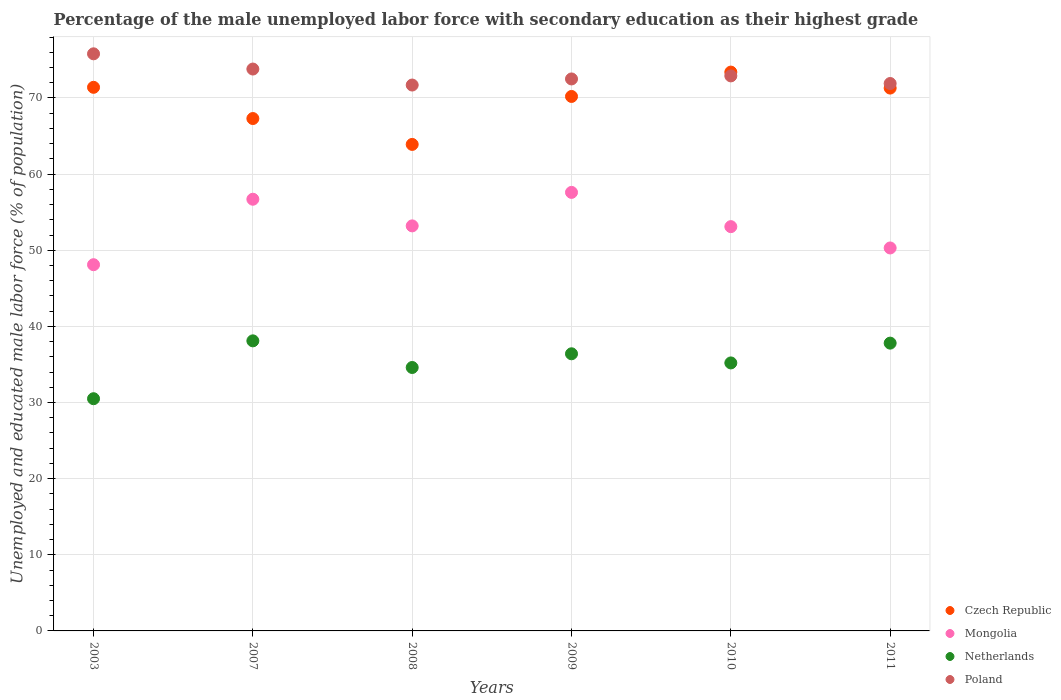Is the number of dotlines equal to the number of legend labels?
Make the answer very short. Yes. What is the percentage of the unemployed male labor force with secondary education in Poland in 2003?
Offer a very short reply. 75.8. Across all years, what is the maximum percentage of the unemployed male labor force with secondary education in Czech Republic?
Ensure brevity in your answer.  73.4. Across all years, what is the minimum percentage of the unemployed male labor force with secondary education in Czech Republic?
Your answer should be very brief. 63.9. In which year was the percentage of the unemployed male labor force with secondary education in Netherlands maximum?
Your answer should be compact. 2007. In which year was the percentage of the unemployed male labor force with secondary education in Czech Republic minimum?
Your answer should be very brief. 2008. What is the total percentage of the unemployed male labor force with secondary education in Mongolia in the graph?
Make the answer very short. 319. What is the difference between the percentage of the unemployed male labor force with secondary education in Poland in 2003 and the percentage of the unemployed male labor force with secondary education in Netherlands in 2010?
Offer a very short reply. 40.6. What is the average percentage of the unemployed male labor force with secondary education in Czech Republic per year?
Offer a terse response. 69.58. In the year 2008, what is the difference between the percentage of the unemployed male labor force with secondary education in Czech Republic and percentage of the unemployed male labor force with secondary education in Mongolia?
Make the answer very short. 10.7. What is the ratio of the percentage of the unemployed male labor force with secondary education in Mongolia in 2007 to that in 2010?
Provide a short and direct response. 1.07. Is the percentage of the unemployed male labor force with secondary education in Poland in 2010 less than that in 2011?
Ensure brevity in your answer.  No. What is the difference between the highest and the second highest percentage of the unemployed male labor force with secondary education in Czech Republic?
Your response must be concise. 2. What is the difference between the highest and the lowest percentage of the unemployed male labor force with secondary education in Czech Republic?
Provide a succinct answer. 9.5. Is it the case that in every year, the sum of the percentage of the unemployed male labor force with secondary education in Netherlands and percentage of the unemployed male labor force with secondary education in Mongolia  is greater than the sum of percentage of the unemployed male labor force with secondary education in Poland and percentage of the unemployed male labor force with secondary education in Czech Republic?
Keep it short and to the point. No. Is it the case that in every year, the sum of the percentage of the unemployed male labor force with secondary education in Mongolia and percentage of the unemployed male labor force with secondary education in Netherlands  is greater than the percentage of the unemployed male labor force with secondary education in Poland?
Provide a succinct answer. Yes. Does the percentage of the unemployed male labor force with secondary education in Czech Republic monotonically increase over the years?
Provide a succinct answer. No. How many years are there in the graph?
Your answer should be compact. 6. Does the graph contain any zero values?
Offer a terse response. No. Does the graph contain grids?
Offer a very short reply. Yes. Where does the legend appear in the graph?
Your response must be concise. Bottom right. How are the legend labels stacked?
Offer a terse response. Vertical. What is the title of the graph?
Ensure brevity in your answer.  Percentage of the male unemployed labor force with secondary education as their highest grade. Does "Brazil" appear as one of the legend labels in the graph?
Provide a short and direct response. No. What is the label or title of the Y-axis?
Your response must be concise. Unemployed and educated male labor force (% of population). What is the Unemployed and educated male labor force (% of population) of Czech Republic in 2003?
Ensure brevity in your answer.  71.4. What is the Unemployed and educated male labor force (% of population) of Mongolia in 2003?
Your answer should be very brief. 48.1. What is the Unemployed and educated male labor force (% of population) in Netherlands in 2003?
Provide a short and direct response. 30.5. What is the Unemployed and educated male labor force (% of population) in Poland in 2003?
Offer a very short reply. 75.8. What is the Unemployed and educated male labor force (% of population) of Czech Republic in 2007?
Make the answer very short. 67.3. What is the Unemployed and educated male labor force (% of population) of Mongolia in 2007?
Keep it short and to the point. 56.7. What is the Unemployed and educated male labor force (% of population) of Netherlands in 2007?
Provide a succinct answer. 38.1. What is the Unemployed and educated male labor force (% of population) in Poland in 2007?
Keep it short and to the point. 73.8. What is the Unemployed and educated male labor force (% of population) in Czech Republic in 2008?
Offer a terse response. 63.9. What is the Unemployed and educated male labor force (% of population) in Mongolia in 2008?
Your answer should be compact. 53.2. What is the Unemployed and educated male labor force (% of population) in Netherlands in 2008?
Offer a very short reply. 34.6. What is the Unemployed and educated male labor force (% of population) of Poland in 2008?
Provide a succinct answer. 71.7. What is the Unemployed and educated male labor force (% of population) of Czech Republic in 2009?
Your answer should be very brief. 70.2. What is the Unemployed and educated male labor force (% of population) of Mongolia in 2009?
Make the answer very short. 57.6. What is the Unemployed and educated male labor force (% of population) in Netherlands in 2009?
Your response must be concise. 36.4. What is the Unemployed and educated male labor force (% of population) in Poland in 2009?
Make the answer very short. 72.5. What is the Unemployed and educated male labor force (% of population) of Czech Republic in 2010?
Keep it short and to the point. 73.4. What is the Unemployed and educated male labor force (% of population) of Mongolia in 2010?
Your answer should be compact. 53.1. What is the Unemployed and educated male labor force (% of population) in Netherlands in 2010?
Your answer should be very brief. 35.2. What is the Unemployed and educated male labor force (% of population) of Poland in 2010?
Your response must be concise. 72.9. What is the Unemployed and educated male labor force (% of population) of Czech Republic in 2011?
Offer a very short reply. 71.3. What is the Unemployed and educated male labor force (% of population) in Mongolia in 2011?
Give a very brief answer. 50.3. What is the Unemployed and educated male labor force (% of population) of Netherlands in 2011?
Give a very brief answer. 37.8. What is the Unemployed and educated male labor force (% of population) of Poland in 2011?
Keep it short and to the point. 71.9. Across all years, what is the maximum Unemployed and educated male labor force (% of population) of Czech Republic?
Offer a very short reply. 73.4. Across all years, what is the maximum Unemployed and educated male labor force (% of population) in Mongolia?
Give a very brief answer. 57.6. Across all years, what is the maximum Unemployed and educated male labor force (% of population) in Netherlands?
Offer a very short reply. 38.1. Across all years, what is the maximum Unemployed and educated male labor force (% of population) of Poland?
Offer a very short reply. 75.8. Across all years, what is the minimum Unemployed and educated male labor force (% of population) of Czech Republic?
Your answer should be very brief. 63.9. Across all years, what is the minimum Unemployed and educated male labor force (% of population) of Mongolia?
Your answer should be compact. 48.1. Across all years, what is the minimum Unemployed and educated male labor force (% of population) of Netherlands?
Your response must be concise. 30.5. Across all years, what is the minimum Unemployed and educated male labor force (% of population) of Poland?
Provide a short and direct response. 71.7. What is the total Unemployed and educated male labor force (% of population) in Czech Republic in the graph?
Your answer should be compact. 417.5. What is the total Unemployed and educated male labor force (% of population) of Mongolia in the graph?
Offer a terse response. 319. What is the total Unemployed and educated male labor force (% of population) of Netherlands in the graph?
Offer a very short reply. 212.6. What is the total Unemployed and educated male labor force (% of population) of Poland in the graph?
Give a very brief answer. 438.6. What is the difference between the Unemployed and educated male labor force (% of population) in Czech Republic in 2003 and that in 2007?
Make the answer very short. 4.1. What is the difference between the Unemployed and educated male labor force (% of population) in Netherlands in 2003 and that in 2007?
Your response must be concise. -7.6. What is the difference between the Unemployed and educated male labor force (% of population) of Poland in 2003 and that in 2007?
Provide a short and direct response. 2. What is the difference between the Unemployed and educated male labor force (% of population) in Poland in 2003 and that in 2008?
Your answer should be very brief. 4.1. What is the difference between the Unemployed and educated male labor force (% of population) of Czech Republic in 2003 and that in 2009?
Your answer should be very brief. 1.2. What is the difference between the Unemployed and educated male labor force (% of population) in Netherlands in 2003 and that in 2009?
Your answer should be very brief. -5.9. What is the difference between the Unemployed and educated male labor force (% of population) in Poland in 2003 and that in 2009?
Provide a succinct answer. 3.3. What is the difference between the Unemployed and educated male labor force (% of population) in Mongolia in 2003 and that in 2010?
Give a very brief answer. -5. What is the difference between the Unemployed and educated male labor force (% of population) of Netherlands in 2003 and that in 2010?
Your answer should be compact. -4.7. What is the difference between the Unemployed and educated male labor force (% of population) in Poland in 2003 and that in 2010?
Give a very brief answer. 2.9. What is the difference between the Unemployed and educated male labor force (% of population) in Czech Republic in 2003 and that in 2011?
Give a very brief answer. 0.1. What is the difference between the Unemployed and educated male labor force (% of population) in Mongolia in 2003 and that in 2011?
Provide a short and direct response. -2.2. What is the difference between the Unemployed and educated male labor force (% of population) of Netherlands in 2003 and that in 2011?
Ensure brevity in your answer.  -7.3. What is the difference between the Unemployed and educated male labor force (% of population) in Poland in 2003 and that in 2011?
Make the answer very short. 3.9. What is the difference between the Unemployed and educated male labor force (% of population) in Czech Republic in 2007 and that in 2008?
Offer a very short reply. 3.4. What is the difference between the Unemployed and educated male labor force (% of population) in Mongolia in 2007 and that in 2008?
Provide a succinct answer. 3.5. What is the difference between the Unemployed and educated male labor force (% of population) in Netherlands in 2007 and that in 2008?
Provide a short and direct response. 3.5. What is the difference between the Unemployed and educated male labor force (% of population) of Poland in 2007 and that in 2008?
Offer a terse response. 2.1. What is the difference between the Unemployed and educated male labor force (% of population) in Mongolia in 2007 and that in 2009?
Make the answer very short. -0.9. What is the difference between the Unemployed and educated male labor force (% of population) in Poland in 2007 and that in 2009?
Your answer should be very brief. 1.3. What is the difference between the Unemployed and educated male labor force (% of population) of Mongolia in 2007 and that in 2010?
Provide a succinct answer. 3.6. What is the difference between the Unemployed and educated male labor force (% of population) of Poland in 2007 and that in 2010?
Provide a short and direct response. 0.9. What is the difference between the Unemployed and educated male labor force (% of population) in Mongolia in 2007 and that in 2011?
Offer a terse response. 6.4. What is the difference between the Unemployed and educated male labor force (% of population) of Netherlands in 2007 and that in 2011?
Make the answer very short. 0.3. What is the difference between the Unemployed and educated male labor force (% of population) of Poland in 2007 and that in 2011?
Your response must be concise. 1.9. What is the difference between the Unemployed and educated male labor force (% of population) in Mongolia in 2008 and that in 2010?
Keep it short and to the point. 0.1. What is the difference between the Unemployed and educated male labor force (% of population) of Mongolia in 2008 and that in 2011?
Keep it short and to the point. 2.9. What is the difference between the Unemployed and educated male labor force (% of population) in Poland in 2008 and that in 2011?
Provide a succinct answer. -0.2. What is the difference between the Unemployed and educated male labor force (% of population) of Mongolia in 2009 and that in 2010?
Provide a short and direct response. 4.5. What is the difference between the Unemployed and educated male labor force (% of population) in Netherlands in 2009 and that in 2010?
Ensure brevity in your answer.  1.2. What is the difference between the Unemployed and educated male labor force (% of population) of Poland in 2009 and that in 2010?
Offer a terse response. -0.4. What is the difference between the Unemployed and educated male labor force (% of population) in Poland in 2009 and that in 2011?
Give a very brief answer. 0.6. What is the difference between the Unemployed and educated male labor force (% of population) in Czech Republic in 2010 and that in 2011?
Your answer should be very brief. 2.1. What is the difference between the Unemployed and educated male labor force (% of population) of Mongolia in 2010 and that in 2011?
Offer a terse response. 2.8. What is the difference between the Unemployed and educated male labor force (% of population) in Netherlands in 2010 and that in 2011?
Provide a short and direct response. -2.6. What is the difference between the Unemployed and educated male labor force (% of population) of Czech Republic in 2003 and the Unemployed and educated male labor force (% of population) of Mongolia in 2007?
Ensure brevity in your answer.  14.7. What is the difference between the Unemployed and educated male labor force (% of population) in Czech Republic in 2003 and the Unemployed and educated male labor force (% of population) in Netherlands in 2007?
Provide a succinct answer. 33.3. What is the difference between the Unemployed and educated male labor force (% of population) of Mongolia in 2003 and the Unemployed and educated male labor force (% of population) of Poland in 2007?
Make the answer very short. -25.7. What is the difference between the Unemployed and educated male labor force (% of population) in Netherlands in 2003 and the Unemployed and educated male labor force (% of population) in Poland in 2007?
Provide a short and direct response. -43.3. What is the difference between the Unemployed and educated male labor force (% of population) in Czech Republic in 2003 and the Unemployed and educated male labor force (% of population) in Netherlands in 2008?
Make the answer very short. 36.8. What is the difference between the Unemployed and educated male labor force (% of population) in Mongolia in 2003 and the Unemployed and educated male labor force (% of population) in Poland in 2008?
Offer a very short reply. -23.6. What is the difference between the Unemployed and educated male labor force (% of population) of Netherlands in 2003 and the Unemployed and educated male labor force (% of population) of Poland in 2008?
Provide a succinct answer. -41.2. What is the difference between the Unemployed and educated male labor force (% of population) in Czech Republic in 2003 and the Unemployed and educated male labor force (% of population) in Netherlands in 2009?
Offer a very short reply. 35. What is the difference between the Unemployed and educated male labor force (% of population) of Mongolia in 2003 and the Unemployed and educated male labor force (% of population) of Poland in 2009?
Provide a short and direct response. -24.4. What is the difference between the Unemployed and educated male labor force (% of population) of Netherlands in 2003 and the Unemployed and educated male labor force (% of population) of Poland in 2009?
Give a very brief answer. -42. What is the difference between the Unemployed and educated male labor force (% of population) in Czech Republic in 2003 and the Unemployed and educated male labor force (% of population) in Netherlands in 2010?
Your answer should be very brief. 36.2. What is the difference between the Unemployed and educated male labor force (% of population) in Mongolia in 2003 and the Unemployed and educated male labor force (% of population) in Netherlands in 2010?
Offer a very short reply. 12.9. What is the difference between the Unemployed and educated male labor force (% of population) of Mongolia in 2003 and the Unemployed and educated male labor force (% of population) of Poland in 2010?
Your answer should be very brief. -24.8. What is the difference between the Unemployed and educated male labor force (% of population) of Netherlands in 2003 and the Unemployed and educated male labor force (% of population) of Poland in 2010?
Make the answer very short. -42.4. What is the difference between the Unemployed and educated male labor force (% of population) in Czech Republic in 2003 and the Unemployed and educated male labor force (% of population) in Mongolia in 2011?
Offer a terse response. 21.1. What is the difference between the Unemployed and educated male labor force (% of population) of Czech Republic in 2003 and the Unemployed and educated male labor force (% of population) of Netherlands in 2011?
Ensure brevity in your answer.  33.6. What is the difference between the Unemployed and educated male labor force (% of population) of Mongolia in 2003 and the Unemployed and educated male labor force (% of population) of Poland in 2011?
Make the answer very short. -23.8. What is the difference between the Unemployed and educated male labor force (% of population) of Netherlands in 2003 and the Unemployed and educated male labor force (% of population) of Poland in 2011?
Your response must be concise. -41.4. What is the difference between the Unemployed and educated male labor force (% of population) in Czech Republic in 2007 and the Unemployed and educated male labor force (% of population) in Netherlands in 2008?
Your response must be concise. 32.7. What is the difference between the Unemployed and educated male labor force (% of population) in Mongolia in 2007 and the Unemployed and educated male labor force (% of population) in Netherlands in 2008?
Provide a short and direct response. 22.1. What is the difference between the Unemployed and educated male labor force (% of population) of Netherlands in 2007 and the Unemployed and educated male labor force (% of population) of Poland in 2008?
Your answer should be very brief. -33.6. What is the difference between the Unemployed and educated male labor force (% of population) of Czech Republic in 2007 and the Unemployed and educated male labor force (% of population) of Netherlands in 2009?
Keep it short and to the point. 30.9. What is the difference between the Unemployed and educated male labor force (% of population) of Czech Republic in 2007 and the Unemployed and educated male labor force (% of population) of Poland in 2009?
Your response must be concise. -5.2. What is the difference between the Unemployed and educated male labor force (% of population) in Mongolia in 2007 and the Unemployed and educated male labor force (% of population) in Netherlands in 2009?
Provide a short and direct response. 20.3. What is the difference between the Unemployed and educated male labor force (% of population) in Mongolia in 2007 and the Unemployed and educated male labor force (% of population) in Poland in 2009?
Give a very brief answer. -15.8. What is the difference between the Unemployed and educated male labor force (% of population) of Netherlands in 2007 and the Unemployed and educated male labor force (% of population) of Poland in 2009?
Your response must be concise. -34.4. What is the difference between the Unemployed and educated male labor force (% of population) in Czech Republic in 2007 and the Unemployed and educated male labor force (% of population) in Netherlands in 2010?
Make the answer very short. 32.1. What is the difference between the Unemployed and educated male labor force (% of population) in Mongolia in 2007 and the Unemployed and educated male labor force (% of population) in Netherlands in 2010?
Your response must be concise. 21.5. What is the difference between the Unemployed and educated male labor force (% of population) of Mongolia in 2007 and the Unemployed and educated male labor force (% of population) of Poland in 2010?
Provide a short and direct response. -16.2. What is the difference between the Unemployed and educated male labor force (% of population) in Netherlands in 2007 and the Unemployed and educated male labor force (% of population) in Poland in 2010?
Offer a very short reply. -34.8. What is the difference between the Unemployed and educated male labor force (% of population) of Czech Republic in 2007 and the Unemployed and educated male labor force (% of population) of Netherlands in 2011?
Make the answer very short. 29.5. What is the difference between the Unemployed and educated male labor force (% of population) in Czech Republic in 2007 and the Unemployed and educated male labor force (% of population) in Poland in 2011?
Offer a very short reply. -4.6. What is the difference between the Unemployed and educated male labor force (% of population) of Mongolia in 2007 and the Unemployed and educated male labor force (% of population) of Netherlands in 2011?
Provide a short and direct response. 18.9. What is the difference between the Unemployed and educated male labor force (% of population) of Mongolia in 2007 and the Unemployed and educated male labor force (% of population) of Poland in 2011?
Offer a very short reply. -15.2. What is the difference between the Unemployed and educated male labor force (% of population) of Netherlands in 2007 and the Unemployed and educated male labor force (% of population) of Poland in 2011?
Offer a terse response. -33.8. What is the difference between the Unemployed and educated male labor force (% of population) of Czech Republic in 2008 and the Unemployed and educated male labor force (% of population) of Mongolia in 2009?
Your response must be concise. 6.3. What is the difference between the Unemployed and educated male labor force (% of population) of Mongolia in 2008 and the Unemployed and educated male labor force (% of population) of Poland in 2009?
Your answer should be very brief. -19.3. What is the difference between the Unemployed and educated male labor force (% of population) in Netherlands in 2008 and the Unemployed and educated male labor force (% of population) in Poland in 2009?
Ensure brevity in your answer.  -37.9. What is the difference between the Unemployed and educated male labor force (% of population) in Czech Republic in 2008 and the Unemployed and educated male labor force (% of population) in Netherlands in 2010?
Your response must be concise. 28.7. What is the difference between the Unemployed and educated male labor force (% of population) of Czech Republic in 2008 and the Unemployed and educated male labor force (% of population) of Poland in 2010?
Offer a terse response. -9. What is the difference between the Unemployed and educated male labor force (% of population) in Mongolia in 2008 and the Unemployed and educated male labor force (% of population) in Netherlands in 2010?
Your answer should be compact. 18. What is the difference between the Unemployed and educated male labor force (% of population) of Mongolia in 2008 and the Unemployed and educated male labor force (% of population) of Poland in 2010?
Make the answer very short. -19.7. What is the difference between the Unemployed and educated male labor force (% of population) of Netherlands in 2008 and the Unemployed and educated male labor force (% of population) of Poland in 2010?
Give a very brief answer. -38.3. What is the difference between the Unemployed and educated male labor force (% of population) in Czech Republic in 2008 and the Unemployed and educated male labor force (% of population) in Mongolia in 2011?
Your response must be concise. 13.6. What is the difference between the Unemployed and educated male labor force (% of population) of Czech Republic in 2008 and the Unemployed and educated male labor force (% of population) of Netherlands in 2011?
Make the answer very short. 26.1. What is the difference between the Unemployed and educated male labor force (% of population) of Czech Republic in 2008 and the Unemployed and educated male labor force (% of population) of Poland in 2011?
Give a very brief answer. -8. What is the difference between the Unemployed and educated male labor force (% of population) of Mongolia in 2008 and the Unemployed and educated male labor force (% of population) of Netherlands in 2011?
Give a very brief answer. 15.4. What is the difference between the Unemployed and educated male labor force (% of population) in Mongolia in 2008 and the Unemployed and educated male labor force (% of population) in Poland in 2011?
Make the answer very short. -18.7. What is the difference between the Unemployed and educated male labor force (% of population) in Netherlands in 2008 and the Unemployed and educated male labor force (% of population) in Poland in 2011?
Keep it short and to the point. -37.3. What is the difference between the Unemployed and educated male labor force (% of population) in Czech Republic in 2009 and the Unemployed and educated male labor force (% of population) in Poland in 2010?
Your answer should be compact. -2.7. What is the difference between the Unemployed and educated male labor force (% of population) in Mongolia in 2009 and the Unemployed and educated male labor force (% of population) in Netherlands in 2010?
Your answer should be compact. 22.4. What is the difference between the Unemployed and educated male labor force (% of population) in Mongolia in 2009 and the Unemployed and educated male labor force (% of population) in Poland in 2010?
Your answer should be very brief. -15.3. What is the difference between the Unemployed and educated male labor force (% of population) in Netherlands in 2009 and the Unemployed and educated male labor force (% of population) in Poland in 2010?
Ensure brevity in your answer.  -36.5. What is the difference between the Unemployed and educated male labor force (% of population) in Czech Republic in 2009 and the Unemployed and educated male labor force (% of population) in Netherlands in 2011?
Make the answer very short. 32.4. What is the difference between the Unemployed and educated male labor force (% of population) of Mongolia in 2009 and the Unemployed and educated male labor force (% of population) of Netherlands in 2011?
Your answer should be compact. 19.8. What is the difference between the Unemployed and educated male labor force (% of population) of Mongolia in 2009 and the Unemployed and educated male labor force (% of population) of Poland in 2011?
Ensure brevity in your answer.  -14.3. What is the difference between the Unemployed and educated male labor force (% of population) of Netherlands in 2009 and the Unemployed and educated male labor force (% of population) of Poland in 2011?
Make the answer very short. -35.5. What is the difference between the Unemployed and educated male labor force (% of population) of Czech Republic in 2010 and the Unemployed and educated male labor force (% of population) of Mongolia in 2011?
Give a very brief answer. 23.1. What is the difference between the Unemployed and educated male labor force (% of population) of Czech Republic in 2010 and the Unemployed and educated male labor force (% of population) of Netherlands in 2011?
Make the answer very short. 35.6. What is the difference between the Unemployed and educated male labor force (% of population) of Mongolia in 2010 and the Unemployed and educated male labor force (% of population) of Netherlands in 2011?
Offer a very short reply. 15.3. What is the difference between the Unemployed and educated male labor force (% of population) in Mongolia in 2010 and the Unemployed and educated male labor force (% of population) in Poland in 2011?
Offer a very short reply. -18.8. What is the difference between the Unemployed and educated male labor force (% of population) of Netherlands in 2010 and the Unemployed and educated male labor force (% of population) of Poland in 2011?
Your answer should be very brief. -36.7. What is the average Unemployed and educated male labor force (% of population) of Czech Republic per year?
Ensure brevity in your answer.  69.58. What is the average Unemployed and educated male labor force (% of population) of Mongolia per year?
Ensure brevity in your answer.  53.17. What is the average Unemployed and educated male labor force (% of population) of Netherlands per year?
Offer a very short reply. 35.43. What is the average Unemployed and educated male labor force (% of population) of Poland per year?
Ensure brevity in your answer.  73.1. In the year 2003, what is the difference between the Unemployed and educated male labor force (% of population) of Czech Republic and Unemployed and educated male labor force (% of population) of Mongolia?
Provide a short and direct response. 23.3. In the year 2003, what is the difference between the Unemployed and educated male labor force (% of population) of Czech Republic and Unemployed and educated male labor force (% of population) of Netherlands?
Provide a short and direct response. 40.9. In the year 2003, what is the difference between the Unemployed and educated male labor force (% of population) in Czech Republic and Unemployed and educated male labor force (% of population) in Poland?
Your answer should be compact. -4.4. In the year 2003, what is the difference between the Unemployed and educated male labor force (% of population) in Mongolia and Unemployed and educated male labor force (% of population) in Poland?
Your response must be concise. -27.7. In the year 2003, what is the difference between the Unemployed and educated male labor force (% of population) of Netherlands and Unemployed and educated male labor force (% of population) of Poland?
Provide a succinct answer. -45.3. In the year 2007, what is the difference between the Unemployed and educated male labor force (% of population) of Czech Republic and Unemployed and educated male labor force (% of population) of Netherlands?
Your answer should be compact. 29.2. In the year 2007, what is the difference between the Unemployed and educated male labor force (% of population) of Mongolia and Unemployed and educated male labor force (% of population) of Poland?
Your answer should be very brief. -17.1. In the year 2007, what is the difference between the Unemployed and educated male labor force (% of population) in Netherlands and Unemployed and educated male labor force (% of population) in Poland?
Provide a succinct answer. -35.7. In the year 2008, what is the difference between the Unemployed and educated male labor force (% of population) of Czech Republic and Unemployed and educated male labor force (% of population) of Mongolia?
Your response must be concise. 10.7. In the year 2008, what is the difference between the Unemployed and educated male labor force (% of population) of Czech Republic and Unemployed and educated male labor force (% of population) of Netherlands?
Your answer should be compact. 29.3. In the year 2008, what is the difference between the Unemployed and educated male labor force (% of population) in Mongolia and Unemployed and educated male labor force (% of population) in Poland?
Provide a short and direct response. -18.5. In the year 2008, what is the difference between the Unemployed and educated male labor force (% of population) of Netherlands and Unemployed and educated male labor force (% of population) of Poland?
Keep it short and to the point. -37.1. In the year 2009, what is the difference between the Unemployed and educated male labor force (% of population) of Czech Republic and Unemployed and educated male labor force (% of population) of Netherlands?
Offer a very short reply. 33.8. In the year 2009, what is the difference between the Unemployed and educated male labor force (% of population) in Mongolia and Unemployed and educated male labor force (% of population) in Netherlands?
Provide a succinct answer. 21.2. In the year 2009, what is the difference between the Unemployed and educated male labor force (% of population) of Mongolia and Unemployed and educated male labor force (% of population) of Poland?
Make the answer very short. -14.9. In the year 2009, what is the difference between the Unemployed and educated male labor force (% of population) in Netherlands and Unemployed and educated male labor force (% of population) in Poland?
Offer a terse response. -36.1. In the year 2010, what is the difference between the Unemployed and educated male labor force (% of population) of Czech Republic and Unemployed and educated male labor force (% of population) of Mongolia?
Offer a terse response. 20.3. In the year 2010, what is the difference between the Unemployed and educated male labor force (% of population) in Czech Republic and Unemployed and educated male labor force (% of population) in Netherlands?
Ensure brevity in your answer.  38.2. In the year 2010, what is the difference between the Unemployed and educated male labor force (% of population) of Czech Republic and Unemployed and educated male labor force (% of population) of Poland?
Your answer should be compact. 0.5. In the year 2010, what is the difference between the Unemployed and educated male labor force (% of population) in Mongolia and Unemployed and educated male labor force (% of population) in Poland?
Provide a short and direct response. -19.8. In the year 2010, what is the difference between the Unemployed and educated male labor force (% of population) in Netherlands and Unemployed and educated male labor force (% of population) in Poland?
Offer a very short reply. -37.7. In the year 2011, what is the difference between the Unemployed and educated male labor force (% of population) of Czech Republic and Unemployed and educated male labor force (% of population) of Mongolia?
Your response must be concise. 21. In the year 2011, what is the difference between the Unemployed and educated male labor force (% of population) of Czech Republic and Unemployed and educated male labor force (% of population) of Netherlands?
Offer a very short reply. 33.5. In the year 2011, what is the difference between the Unemployed and educated male labor force (% of population) in Czech Republic and Unemployed and educated male labor force (% of population) in Poland?
Give a very brief answer. -0.6. In the year 2011, what is the difference between the Unemployed and educated male labor force (% of population) of Mongolia and Unemployed and educated male labor force (% of population) of Netherlands?
Your answer should be compact. 12.5. In the year 2011, what is the difference between the Unemployed and educated male labor force (% of population) of Mongolia and Unemployed and educated male labor force (% of population) of Poland?
Your answer should be very brief. -21.6. In the year 2011, what is the difference between the Unemployed and educated male labor force (% of population) in Netherlands and Unemployed and educated male labor force (% of population) in Poland?
Your answer should be compact. -34.1. What is the ratio of the Unemployed and educated male labor force (% of population) of Czech Republic in 2003 to that in 2007?
Offer a very short reply. 1.06. What is the ratio of the Unemployed and educated male labor force (% of population) of Mongolia in 2003 to that in 2007?
Provide a succinct answer. 0.85. What is the ratio of the Unemployed and educated male labor force (% of population) in Netherlands in 2003 to that in 2007?
Offer a terse response. 0.8. What is the ratio of the Unemployed and educated male labor force (% of population) of Poland in 2003 to that in 2007?
Provide a short and direct response. 1.03. What is the ratio of the Unemployed and educated male labor force (% of population) in Czech Republic in 2003 to that in 2008?
Give a very brief answer. 1.12. What is the ratio of the Unemployed and educated male labor force (% of population) of Mongolia in 2003 to that in 2008?
Keep it short and to the point. 0.9. What is the ratio of the Unemployed and educated male labor force (% of population) in Netherlands in 2003 to that in 2008?
Give a very brief answer. 0.88. What is the ratio of the Unemployed and educated male labor force (% of population) in Poland in 2003 to that in 2008?
Provide a succinct answer. 1.06. What is the ratio of the Unemployed and educated male labor force (% of population) in Czech Republic in 2003 to that in 2009?
Provide a short and direct response. 1.02. What is the ratio of the Unemployed and educated male labor force (% of population) in Mongolia in 2003 to that in 2009?
Your response must be concise. 0.84. What is the ratio of the Unemployed and educated male labor force (% of population) of Netherlands in 2003 to that in 2009?
Give a very brief answer. 0.84. What is the ratio of the Unemployed and educated male labor force (% of population) in Poland in 2003 to that in 2009?
Keep it short and to the point. 1.05. What is the ratio of the Unemployed and educated male labor force (% of population) of Czech Republic in 2003 to that in 2010?
Your response must be concise. 0.97. What is the ratio of the Unemployed and educated male labor force (% of population) of Mongolia in 2003 to that in 2010?
Your response must be concise. 0.91. What is the ratio of the Unemployed and educated male labor force (% of population) in Netherlands in 2003 to that in 2010?
Keep it short and to the point. 0.87. What is the ratio of the Unemployed and educated male labor force (% of population) in Poland in 2003 to that in 2010?
Provide a short and direct response. 1.04. What is the ratio of the Unemployed and educated male labor force (% of population) in Czech Republic in 2003 to that in 2011?
Keep it short and to the point. 1. What is the ratio of the Unemployed and educated male labor force (% of population) in Mongolia in 2003 to that in 2011?
Make the answer very short. 0.96. What is the ratio of the Unemployed and educated male labor force (% of population) of Netherlands in 2003 to that in 2011?
Your answer should be very brief. 0.81. What is the ratio of the Unemployed and educated male labor force (% of population) in Poland in 2003 to that in 2011?
Make the answer very short. 1.05. What is the ratio of the Unemployed and educated male labor force (% of population) of Czech Republic in 2007 to that in 2008?
Provide a succinct answer. 1.05. What is the ratio of the Unemployed and educated male labor force (% of population) in Mongolia in 2007 to that in 2008?
Your answer should be very brief. 1.07. What is the ratio of the Unemployed and educated male labor force (% of population) of Netherlands in 2007 to that in 2008?
Your answer should be compact. 1.1. What is the ratio of the Unemployed and educated male labor force (% of population) of Poland in 2007 to that in 2008?
Make the answer very short. 1.03. What is the ratio of the Unemployed and educated male labor force (% of population) of Czech Republic in 2007 to that in 2009?
Provide a short and direct response. 0.96. What is the ratio of the Unemployed and educated male labor force (% of population) of Mongolia in 2007 to that in 2009?
Offer a very short reply. 0.98. What is the ratio of the Unemployed and educated male labor force (% of population) in Netherlands in 2007 to that in 2009?
Keep it short and to the point. 1.05. What is the ratio of the Unemployed and educated male labor force (% of population) of Poland in 2007 to that in 2009?
Make the answer very short. 1.02. What is the ratio of the Unemployed and educated male labor force (% of population) of Czech Republic in 2007 to that in 2010?
Give a very brief answer. 0.92. What is the ratio of the Unemployed and educated male labor force (% of population) of Mongolia in 2007 to that in 2010?
Make the answer very short. 1.07. What is the ratio of the Unemployed and educated male labor force (% of population) in Netherlands in 2007 to that in 2010?
Give a very brief answer. 1.08. What is the ratio of the Unemployed and educated male labor force (% of population) in Poland in 2007 to that in 2010?
Provide a succinct answer. 1.01. What is the ratio of the Unemployed and educated male labor force (% of population) of Czech Republic in 2007 to that in 2011?
Offer a very short reply. 0.94. What is the ratio of the Unemployed and educated male labor force (% of population) in Mongolia in 2007 to that in 2011?
Make the answer very short. 1.13. What is the ratio of the Unemployed and educated male labor force (% of population) of Netherlands in 2007 to that in 2011?
Your answer should be compact. 1.01. What is the ratio of the Unemployed and educated male labor force (% of population) in Poland in 2007 to that in 2011?
Provide a succinct answer. 1.03. What is the ratio of the Unemployed and educated male labor force (% of population) in Czech Republic in 2008 to that in 2009?
Provide a short and direct response. 0.91. What is the ratio of the Unemployed and educated male labor force (% of population) of Mongolia in 2008 to that in 2009?
Your response must be concise. 0.92. What is the ratio of the Unemployed and educated male labor force (% of population) of Netherlands in 2008 to that in 2009?
Ensure brevity in your answer.  0.95. What is the ratio of the Unemployed and educated male labor force (% of population) in Poland in 2008 to that in 2009?
Offer a very short reply. 0.99. What is the ratio of the Unemployed and educated male labor force (% of population) of Czech Republic in 2008 to that in 2010?
Offer a terse response. 0.87. What is the ratio of the Unemployed and educated male labor force (% of population) in Netherlands in 2008 to that in 2010?
Your answer should be very brief. 0.98. What is the ratio of the Unemployed and educated male labor force (% of population) of Poland in 2008 to that in 2010?
Give a very brief answer. 0.98. What is the ratio of the Unemployed and educated male labor force (% of population) of Czech Republic in 2008 to that in 2011?
Provide a short and direct response. 0.9. What is the ratio of the Unemployed and educated male labor force (% of population) in Mongolia in 2008 to that in 2011?
Provide a succinct answer. 1.06. What is the ratio of the Unemployed and educated male labor force (% of population) of Netherlands in 2008 to that in 2011?
Ensure brevity in your answer.  0.92. What is the ratio of the Unemployed and educated male labor force (% of population) of Czech Republic in 2009 to that in 2010?
Provide a succinct answer. 0.96. What is the ratio of the Unemployed and educated male labor force (% of population) in Mongolia in 2009 to that in 2010?
Your response must be concise. 1.08. What is the ratio of the Unemployed and educated male labor force (% of population) of Netherlands in 2009 to that in 2010?
Offer a very short reply. 1.03. What is the ratio of the Unemployed and educated male labor force (% of population) of Poland in 2009 to that in 2010?
Provide a short and direct response. 0.99. What is the ratio of the Unemployed and educated male labor force (% of population) of Czech Republic in 2009 to that in 2011?
Offer a very short reply. 0.98. What is the ratio of the Unemployed and educated male labor force (% of population) in Mongolia in 2009 to that in 2011?
Your answer should be very brief. 1.15. What is the ratio of the Unemployed and educated male labor force (% of population) of Poland in 2009 to that in 2011?
Your response must be concise. 1.01. What is the ratio of the Unemployed and educated male labor force (% of population) in Czech Republic in 2010 to that in 2011?
Offer a very short reply. 1.03. What is the ratio of the Unemployed and educated male labor force (% of population) in Mongolia in 2010 to that in 2011?
Your response must be concise. 1.06. What is the ratio of the Unemployed and educated male labor force (% of population) in Netherlands in 2010 to that in 2011?
Provide a short and direct response. 0.93. What is the ratio of the Unemployed and educated male labor force (% of population) in Poland in 2010 to that in 2011?
Keep it short and to the point. 1.01. What is the difference between the highest and the second highest Unemployed and educated male labor force (% of population) of Mongolia?
Make the answer very short. 0.9. What is the difference between the highest and the second highest Unemployed and educated male labor force (% of population) of Poland?
Provide a short and direct response. 2. What is the difference between the highest and the lowest Unemployed and educated male labor force (% of population) of Mongolia?
Provide a succinct answer. 9.5. What is the difference between the highest and the lowest Unemployed and educated male labor force (% of population) of Netherlands?
Give a very brief answer. 7.6. What is the difference between the highest and the lowest Unemployed and educated male labor force (% of population) in Poland?
Make the answer very short. 4.1. 